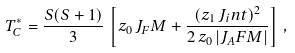Convert formula to latex. <formula><loc_0><loc_0><loc_500><loc_500>T _ { C } ^ { * } = \frac { S ( S + 1 ) } { 3 } \, \left [ z _ { 0 } \, J _ { F } M + \frac { ( z _ { 1 } \, J _ { i } n t ) ^ { 2 } } { 2 \, z _ { 0 } \, | J _ { A } F M | } \right ] \, ,</formula> 